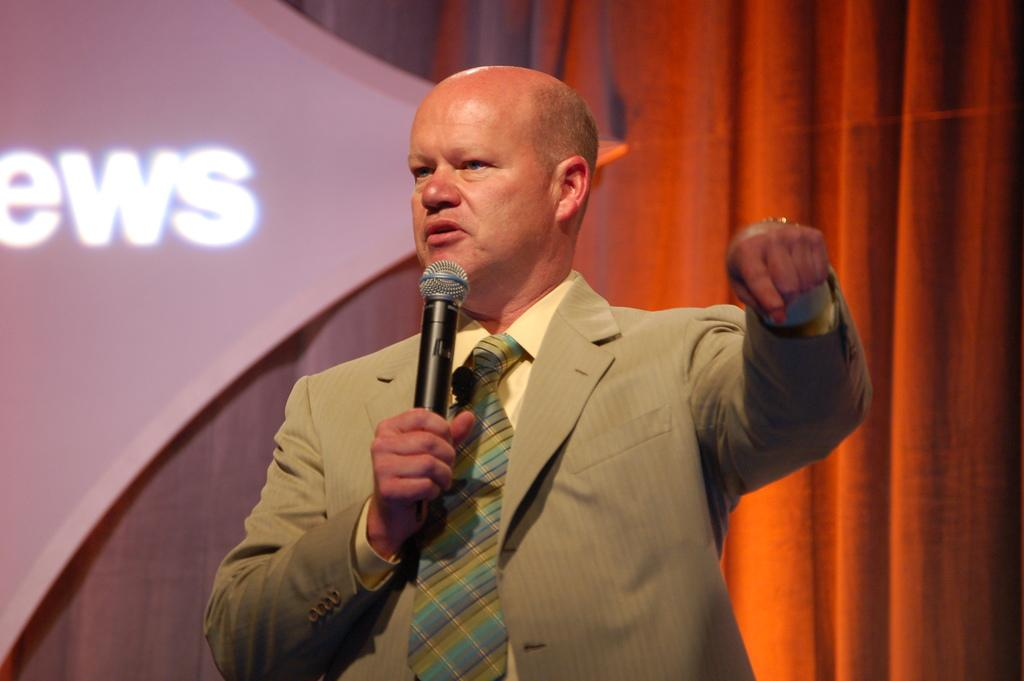What is the main subject of the image? The main subject of the image is a man. What is the man wearing in the image? The man is wearing a brown blazer in the image. What is the man holding in the image? The man is holding a microphone in the image. What is the man doing in the image? The man is explaining something in the image. What is behind the man in the image? There is a curtain and a board behind the man in the image. How does the man maintain his balance while explaining something in the image? The image does not provide information about the man's balance, as he appears to be standing still while explaining something. What type of mine is depicted in the image? There is no mine present in the image; it features a man explaining something while holding a microphone. 